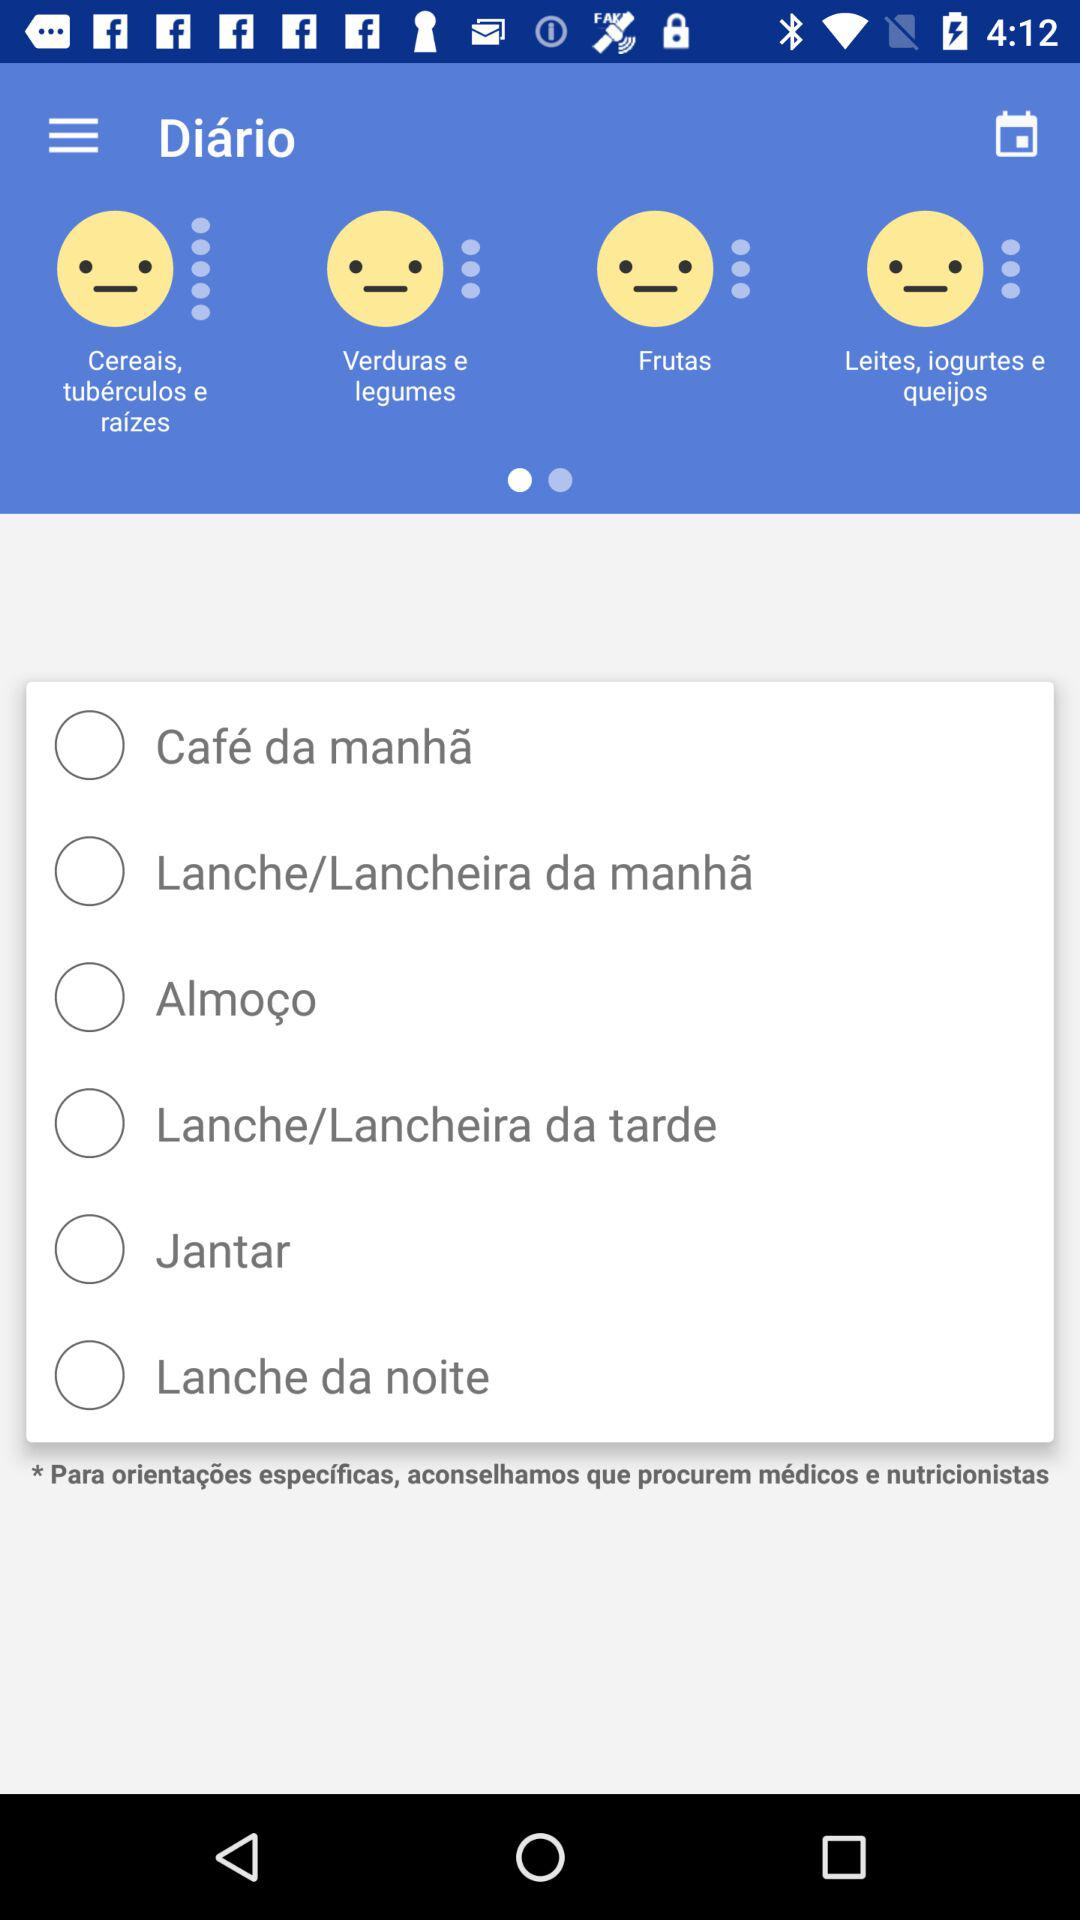How many meals are there?
Answer the question using a single word or phrase. 6 